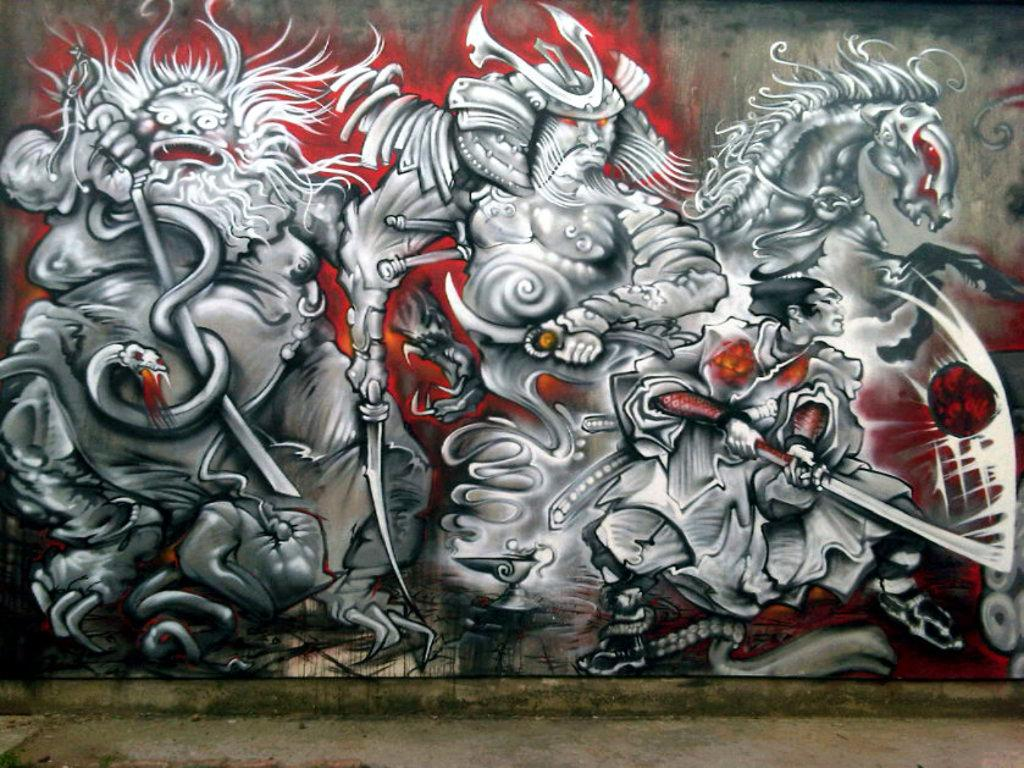What is hanging on the wall in the image? There is a painting on the wall in the image. Can you see a swing in the image? No, there is no swing present in the image. 